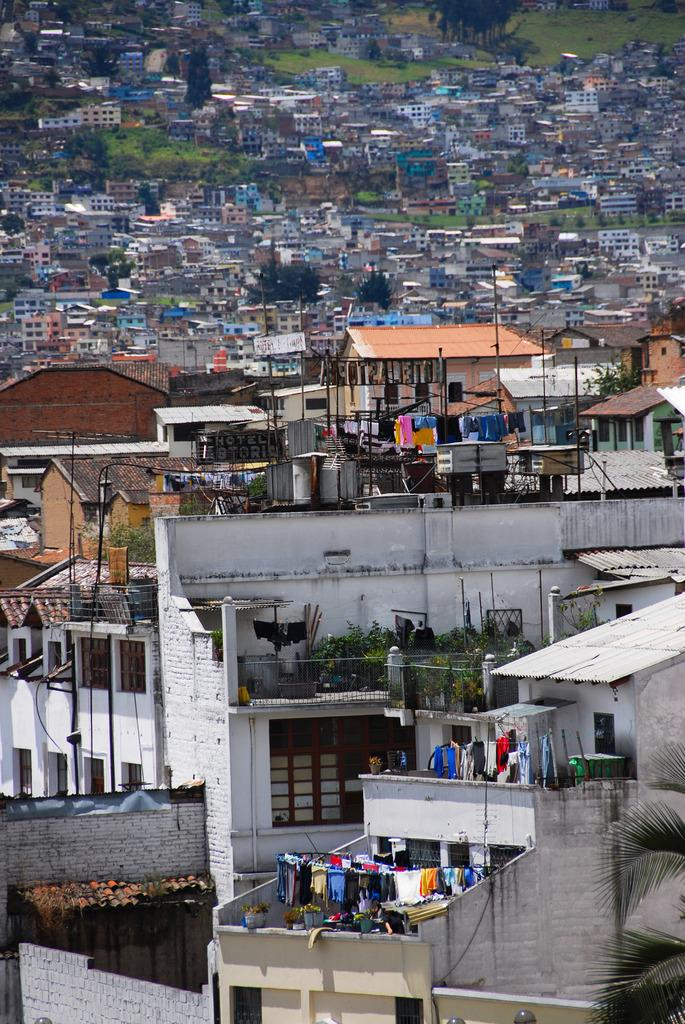What type of structures can be seen in the image? There are buildings in the image. What natural elements are present in the image? There are trees and grass in the image. What is being used to dry clothes in the image? Clothes are hanging from ropes at the bottom of the image. Where are plants located in the image? There are plants on top of a building in the image. What type of bun is being used to hold up the plants on the building in the image? There is no bun present in the image; the plants are simply located on top of a building. 